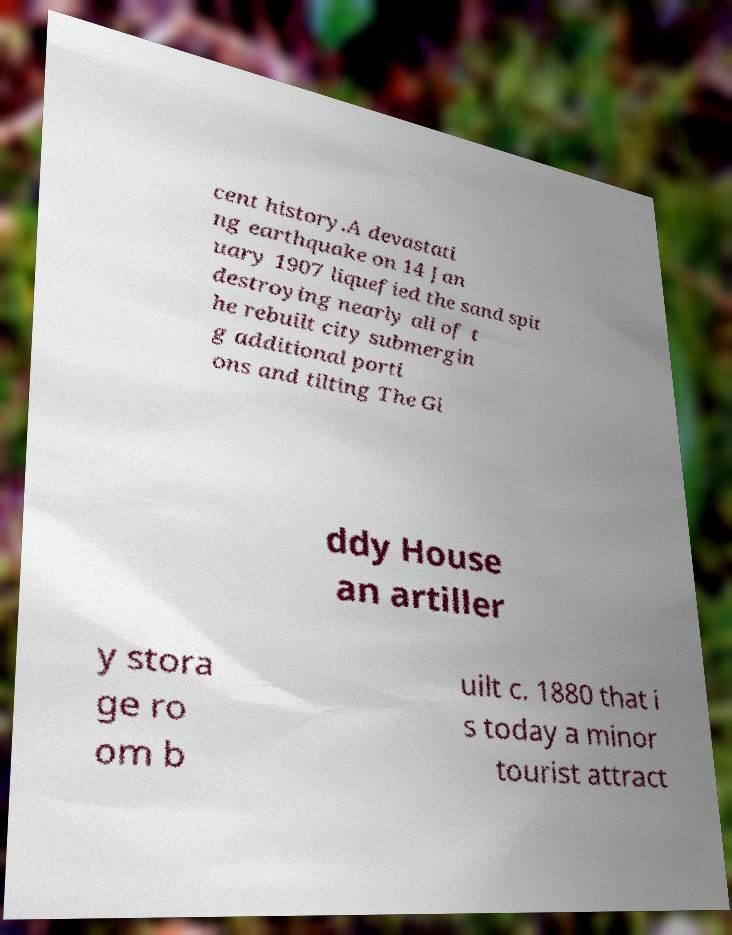Can you accurately transcribe the text from the provided image for me? cent history.A devastati ng earthquake on 14 Jan uary 1907 liquefied the sand spit destroying nearly all of t he rebuilt city submergin g additional porti ons and tilting The Gi ddy House an artiller y stora ge ro om b uilt c. 1880 that i s today a minor tourist attract 